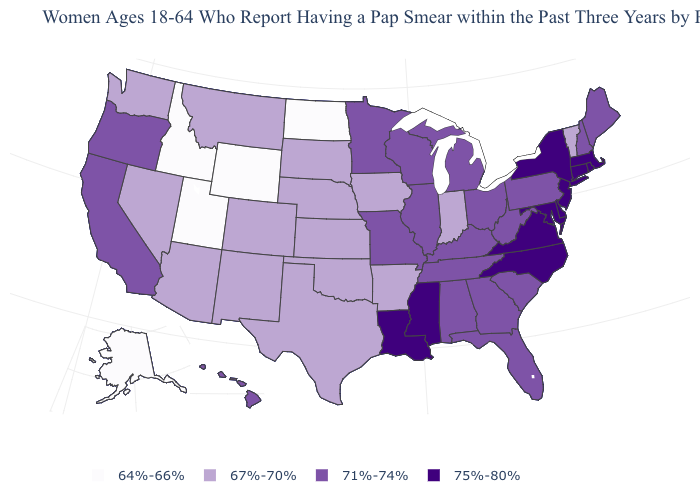Name the states that have a value in the range 64%-66%?
Keep it brief. Alaska, Idaho, North Dakota, Utah, Wyoming. Name the states that have a value in the range 75%-80%?
Give a very brief answer. Connecticut, Delaware, Louisiana, Maryland, Massachusetts, Mississippi, New Jersey, New York, North Carolina, Rhode Island, Virginia. How many symbols are there in the legend?
Short answer required. 4. Does Maryland have the same value as Hawaii?
Be succinct. No. Which states have the highest value in the USA?
Short answer required. Connecticut, Delaware, Louisiana, Maryland, Massachusetts, Mississippi, New Jersey, New York, North Carolina, Rhode Island, Virginia. What is the value of Massachusetts?
Be succinct. 75%-80%. Does South Dakota have a higher value than New York?
Give a very brief answer. No. What is the lowest value in states that border Pennsylvania?
Write a very short answer. 71%-74%. Which states have the highest value in the USA?
Write a very short answer. Connecticut, Delaware, Louisiana, Maryland, Massachusetts, Mississippi, New Jersey, New York, North Carolina, Rhode Island, Virginia. Is the legend a continuous bar?
Short answer required. No. What is the value of North Dakota?
Quick response, please. 64%-66%. Does Maryland have the same value as Louisiana?
Be succinct. Yes. Among the states that border Texas , does New Mexico have the highest value?
Keep it brief. No. Which states have the lowest value in the Northeast?
Keep it brief. Vermont. Which states hav the highest value in the Northeast?
Concise answer only. Connecticut, Massachusetts, New Jersey, New York, Rhode Island. 